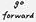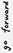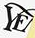Read the text content from these images in order, separated by a semicolon. #; #; YE 